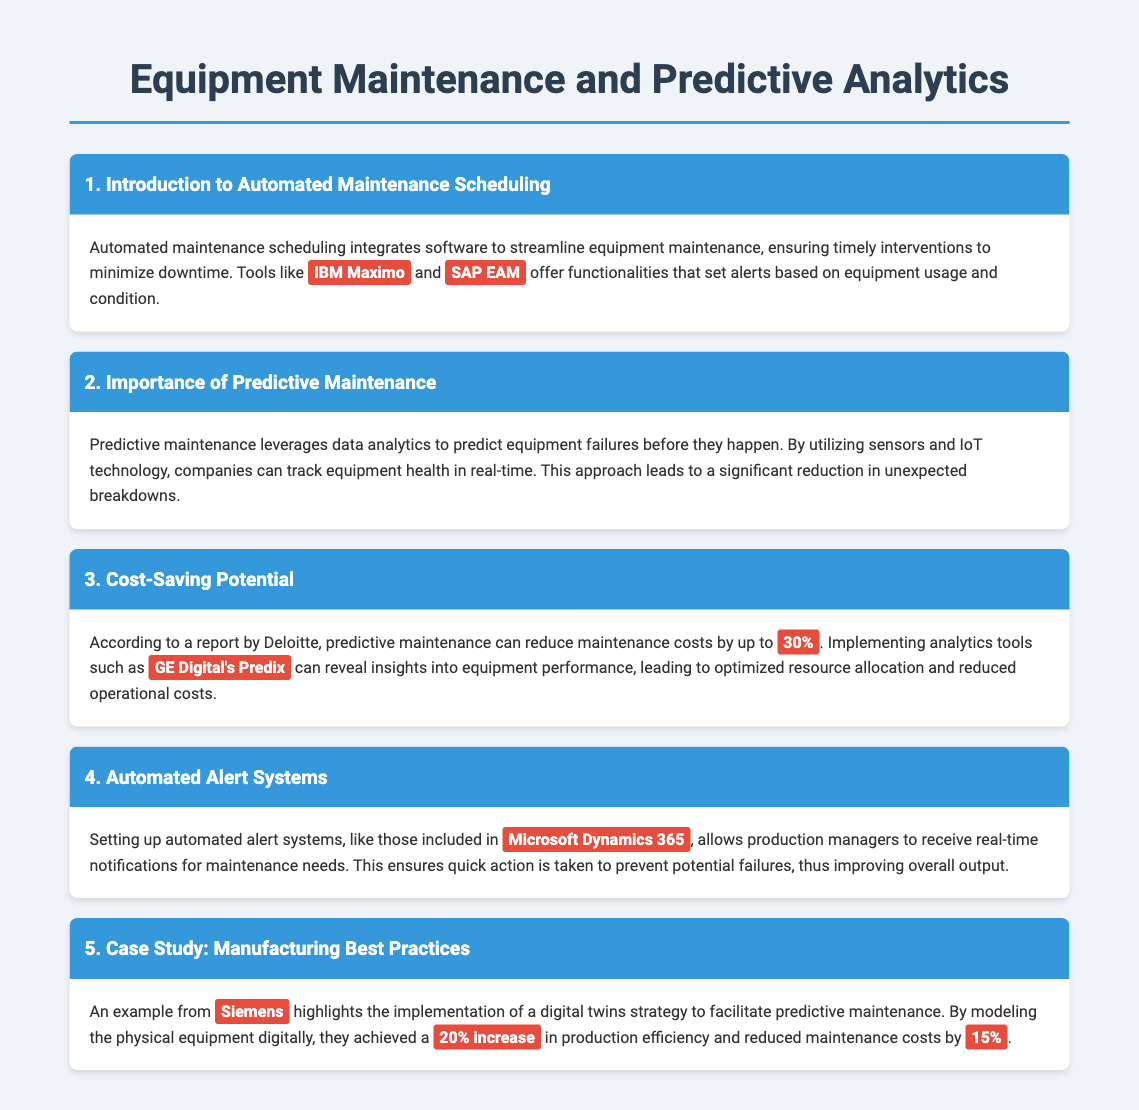What software is mentioned for automated maintenance scheduling? The document lists IBM Maximo and SAP EAM as examples of software for automated maintenance scheduling.
Answer: IBM Maximo, SAP EAM What is the potential percentage reduction in maintenance costs through predictive maintenance? According to the document, predictive maintenance can reduce maintenance costs by up to 30%.
Answer: 30% Which company achieved a 20% increase in production efficiency with predictive maintenance? The case study in the document highlights Siemens as the company that achieved a 20% increase in production efficiency.
Answer: Siemens What is the role of IoT technology in predictive maintenance? The document states that IoT technology allows companies to track equipment health in real time, which is essential for predictive maintenance.
Answer: Track equipment health What analytics tool is mentioned for gaining insights into equipment performance? The document refers to GE Digital's Predix as an analytics tool that provides insights into equipment performance.
Answer: GE Digital's Predix How does automated alert systems benefit production managers? The document explains that automated alert systems provide real-time notifications for maintenance needs, enabling quick action to prevent failures.
Answer: Real-time notifications What was the reduction in maintenance costs achieved by Siemens through digital twins strategy? The document indicates that Siemens reduced maintenance costs by 15% through their digital twins strategy for predictive maintenance.
Answer: 15% What is the significance of automated maintenance scheduling? The document states that automated maintenance scheduling minimizes downtime by ensuring timely interventions for equipment maintenance.
Answer: Minimize downtime 